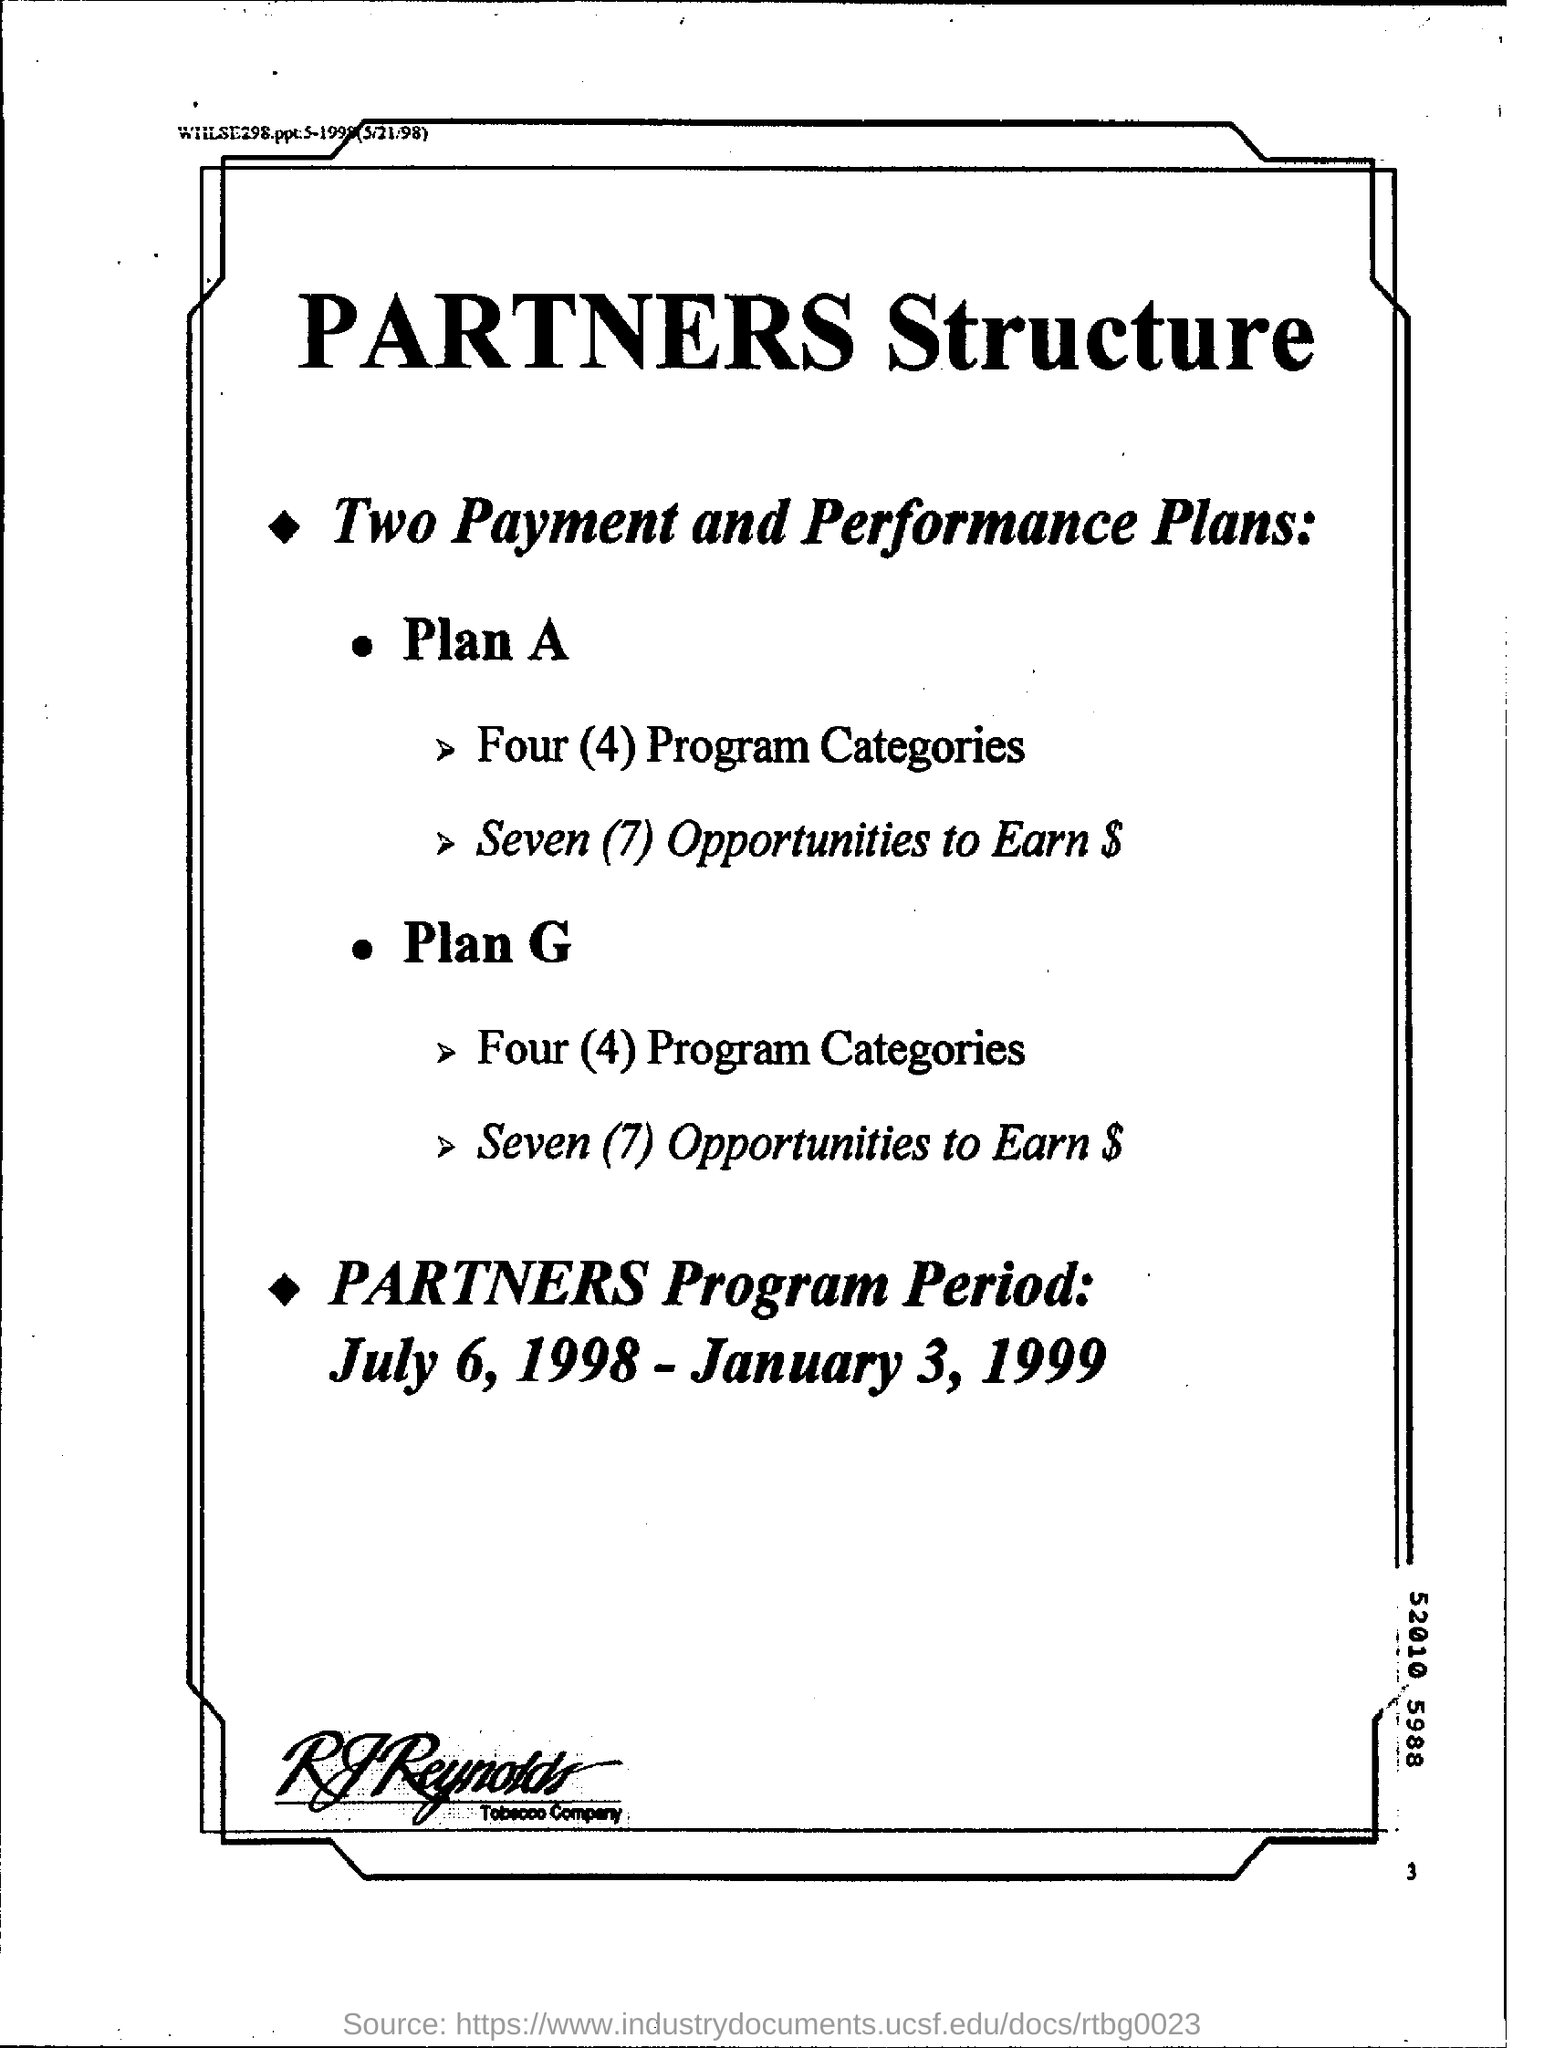List a handful of essential elements in this visual. There are two payment and performance plans. The partners program was active from July 6, 1998, to January 3, 1999. The name of the tobacco company is RJ Reynolds. The number of program categories under Plan G is four. The number in the bottom right corner of the page is 3. 